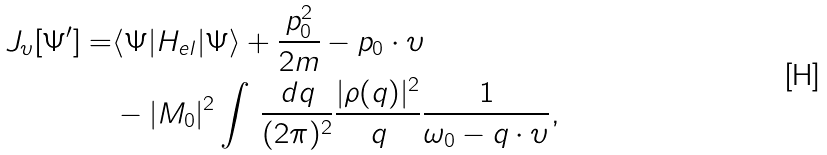Convert formula to latex. <formula><loc_0><loc_0><loc_500><loc_500>J _ { \upsilon } [ \Psi ^ { \prime } ] = & \langle \Psi | H _ { e l } | \Psi \rangle + \frac { p _ { 0 } ^ { 2 } } { 2 m } - { p } _ { 0 } \cdot \upsilon \\ & - | M _ { 0 } | ^ { 2 } \int \, \frac { d { q } } { ( 2 \pi ) ^ { 2 } } \frac { | \rho ( { q } ) | ^ { 2 } } { q } \frac { 1 } { \omega _ { 0 } - { q } \cdot \upsilon } ,</formula> 